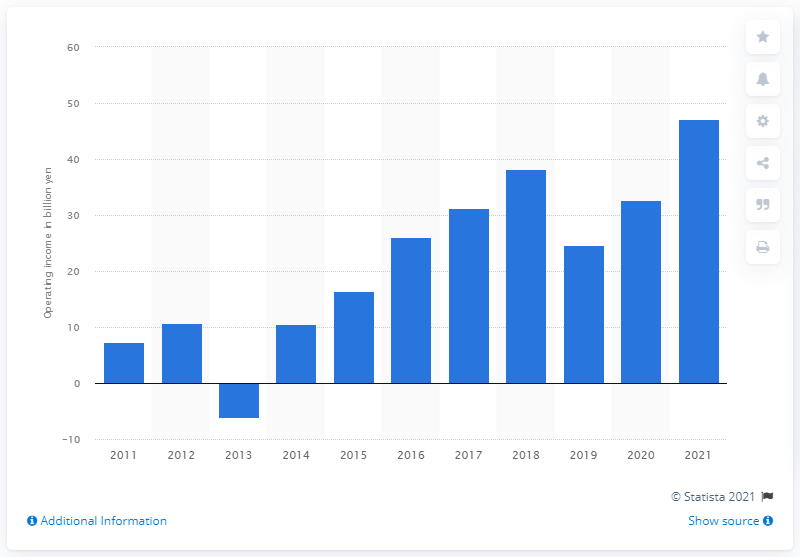Draw attention to some important aspects in this diagram. In 2018, Square Enix reported an increase in operating income. 